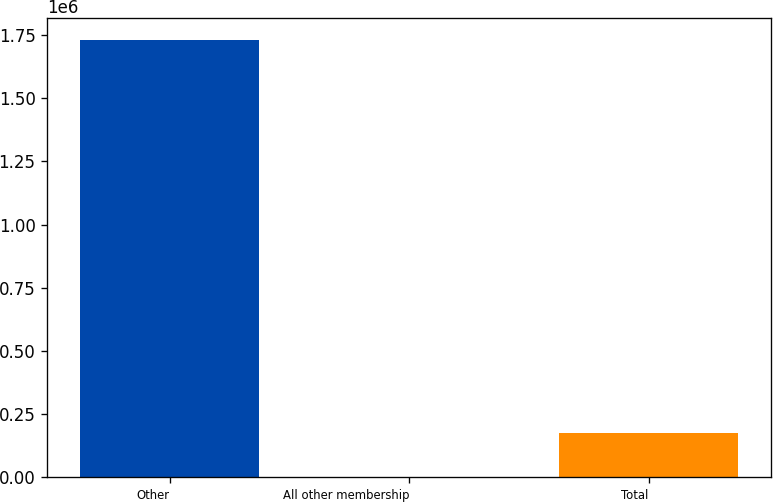<chart> <loc_0><loc_0><loc_500><loc_500><bar_chart><fcel>Other<fcel>All other membership<fcel>Total<nl><fcel>1.7323e+06<fcel>96.1<fcel>173316<nl></chart> 